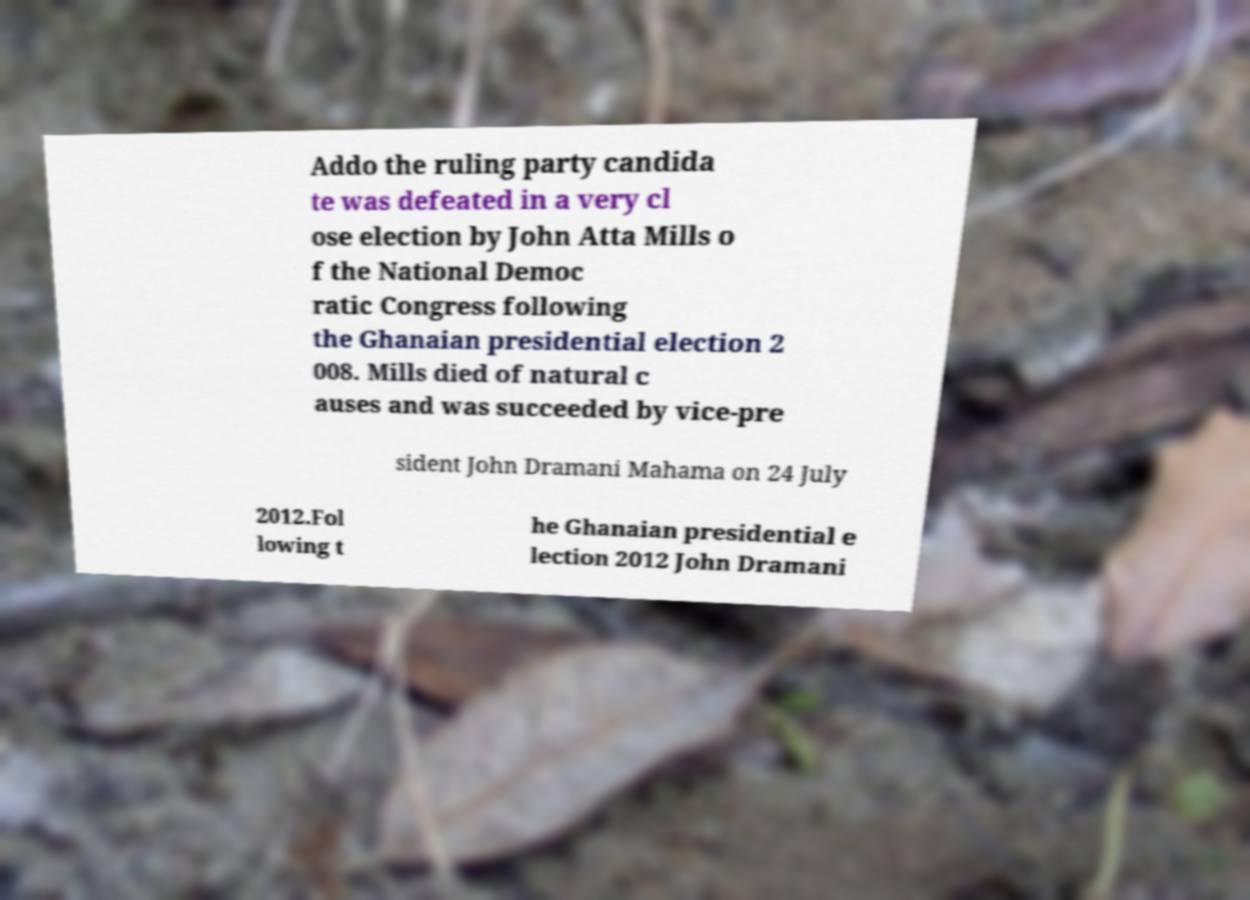I need the written content from this picture converted into text. Can you do that? Addo the ruling party candida te was defeated in a very cl ose election by John Atta Mills o f the National Democ ratic Congress following the Ghanaian presidential election 2 008. Mills died of natural c auses and was succeeded by vice-pre sident John Dramani Mahama on 24 July 2012.Fol lowing t he Ghanaian presidential e lection 2012 John Dramani 